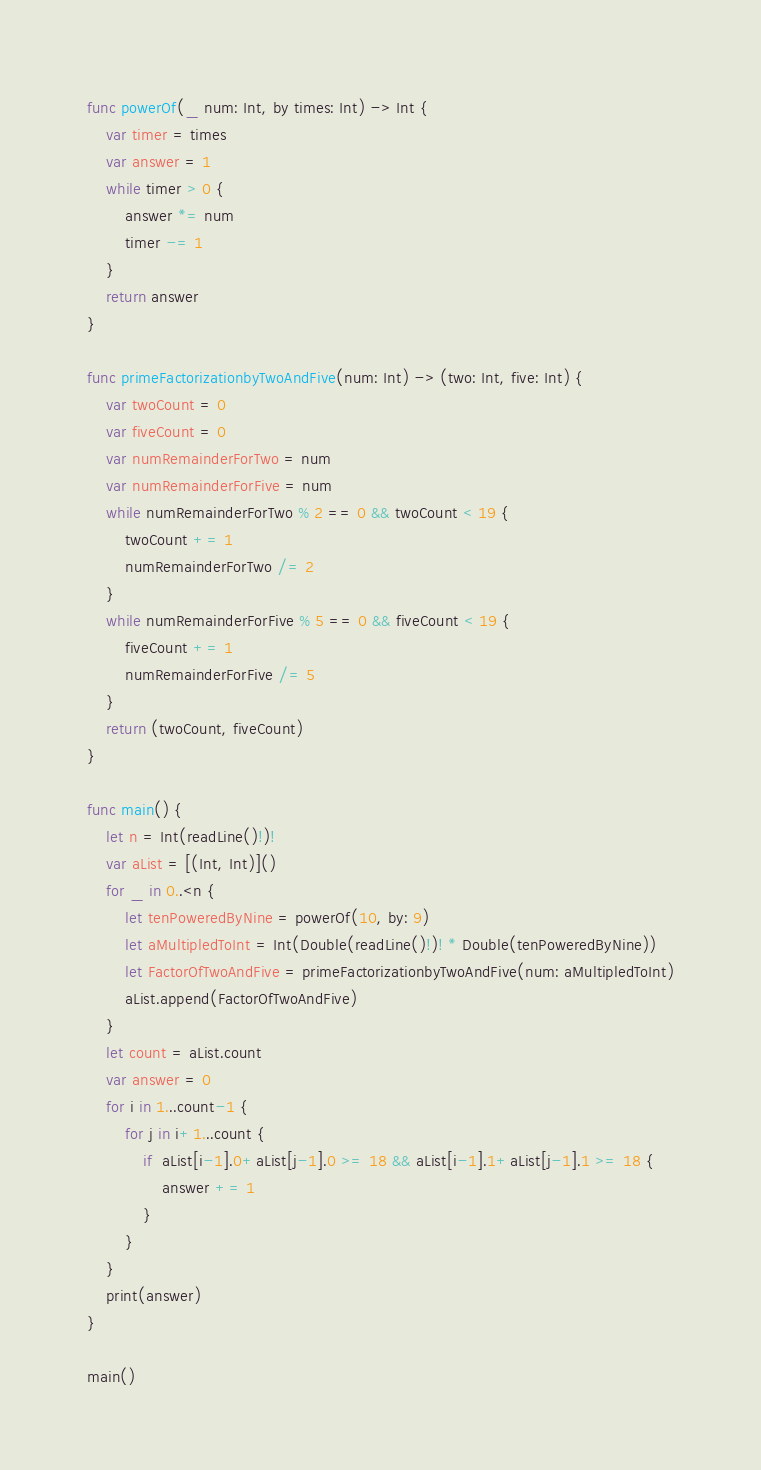Convert code to text. <code><loc_0><loc_0><loc_500><loc_500><_Swift_>func powerOf(_ num: Int, by times: Int) -> Int {
    var timer = times
    var answer = 1
    while timer > 0 {
        answer *= num
        timer -= 1
    }
    return answer
}

func primeFactorizationbyTwoAndFive(num: Int) -> (two: Int, five: Int) {
    var twoCount = 0
    var fiveCount = 0
    var numRemainderForTwo = num
    var numRemainderForFive = num
    while numRemainderForTwo % 2 == 0 && twoCount < 19 {
        twoCount += 1
        numRemainderForTwo /= 2
    }
    while numRemainderForFive % 5 == 0 && fiveCount < 19 {
        fiveCount += 1
        numRemainderForFive /= 5
    }
    return (twoCount, fiveCount)
}

func main() {
    let n = Int(readLine()!)!
    var aList = [(Int, Int)]()
    for _ in 0..<n {
        let tenPoweredByNine = powerOf(10, by: 9)
        let aMultipledToInt = Int(Double(readLine()!)! * Double(tenPoweredByNine))
        let FactorOfTwoAndFive = primeFactorizationbyTwoAndFive(num: aMultipledToInt)
        aList.append(FactorOfTwoAndFive)
    }
    let count = aList.count
    var answer = 0
    for i in 1...count-1 {
        for j in i+1...count {
            if  aList[i-1].0+aList[j-1].0 >= 18 && aList[i-1].1+aList[j-1].1 >= 18 {
                answer += 1
            }
        }
    }
    print(answer)
}

main()

</code> 